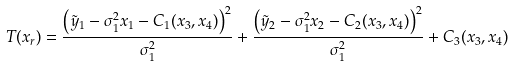Convert formula to latex. <formula><loc_0><loc_0><loc_500><loc_500>T ( x _ { r } ) = \frac { \left ( \tilde { y } _ { 1 } - \sigma ^ { 2 } _ { 1 } x _ { 1 } - C _ { 1 } ( x _ { 3 } , x _ { 4 } ) \right ) ^ { 2 } } { \sigma ^ { 2 } _ { 1 } } + \frac { \left ( \tilde { y } _ { 2 } - \sigma ^ { 2 } _ { 1 } x _ { 2 } - C _ { 2 } ( x _ { 3 } , x _ { 4 } ) \right ) ^ { 2 } } { \sigma ^ { 2 } _ { 1 } } + C _ { 3 } ( x _ { 3 } , x _ { 4 } )</formula> 